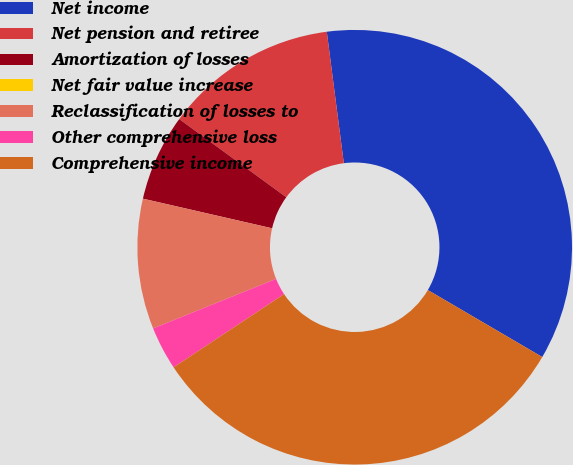Convert chart to OTSL. <chart><loc_0><loc_0><loc_500><loc_500><pie_chart><fcel>Net income<fcel>Net pension and retiree<fcel>Amortization of losses<fcel>Net fair value increase<fcel>Reclassification of losses to<fcel>Other comprehensive loss<fcel>Comprehensive income<nl><fcel>35.48%<fcel>12.91%<fcel>6.45%<fcel>0.0%<fcel>9.68%<fcel>3.23%<fcel>32.25%<nl></chart> 